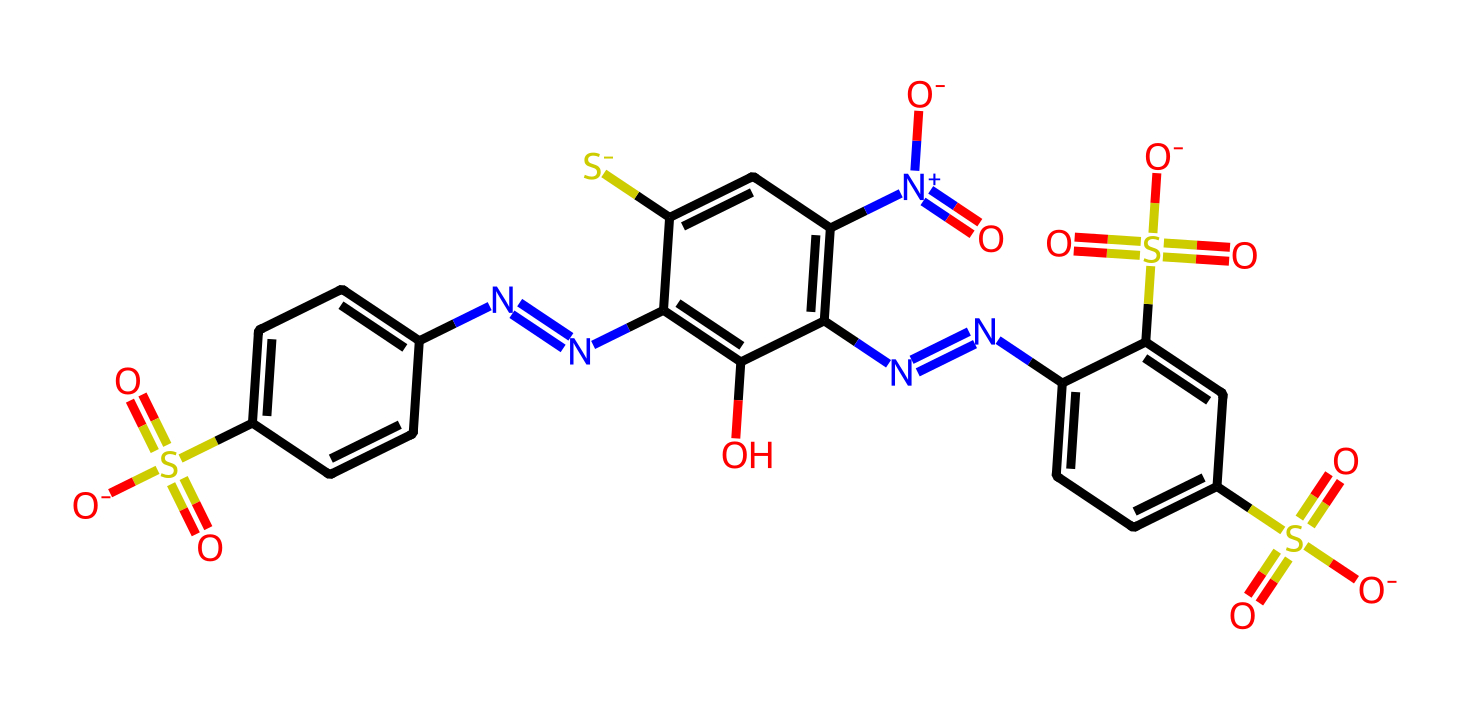What is the molecular formula of tartrazine? The molecular formula can be derived from the atoms present in the chemical structure. By counting the elements: there are 16 carbons (C), 9 hydrogens (H), 4 nitrogens (N), 6 oxygens (O), and 2 sulfurs (S). This gives us the formula C16H9N4O7S2.
Answer: C16H9N4O7S2 How many nitrogen atoms are present in the chemical structure of tartrazine? A quick count of the nitrogen atoms in the structure shows there are 4 nitrogen atoms.
Answer: 4 What type of functional groups are present in tartrazine? By examining the chemical structure, we can identify sulfonic acid groups (-SO3H) and azo groups (-N=N-). Therapeutically important functional groups are relevant for its usage.
Answer: sulfonic and azo groups Which part of the structure indicates that tartrazine is a dye? The presence of multiple sulfonic acid groups in the structure suggests high water solubility, which is a characteristic feature of food dyes, facilitating their use in pharmaceutical coatings.
Answer: sulfonic acid groups What is the significance of the azo (-N=N-) groups in tariffing? The azo groups are characteristic of many synthetic dyes, contributing to color properties and stability, making the dye more viable for pharmaceutical applications.
Answer: color and stability What elements contribute to the negative charge in tartrazine? The negative charge originates from the sulfonate groups, where the sulfur is attached to four oxygen atoms, resulting in one of the oxygens carrying a negative charge.
Answer: sulfur and oxygen 